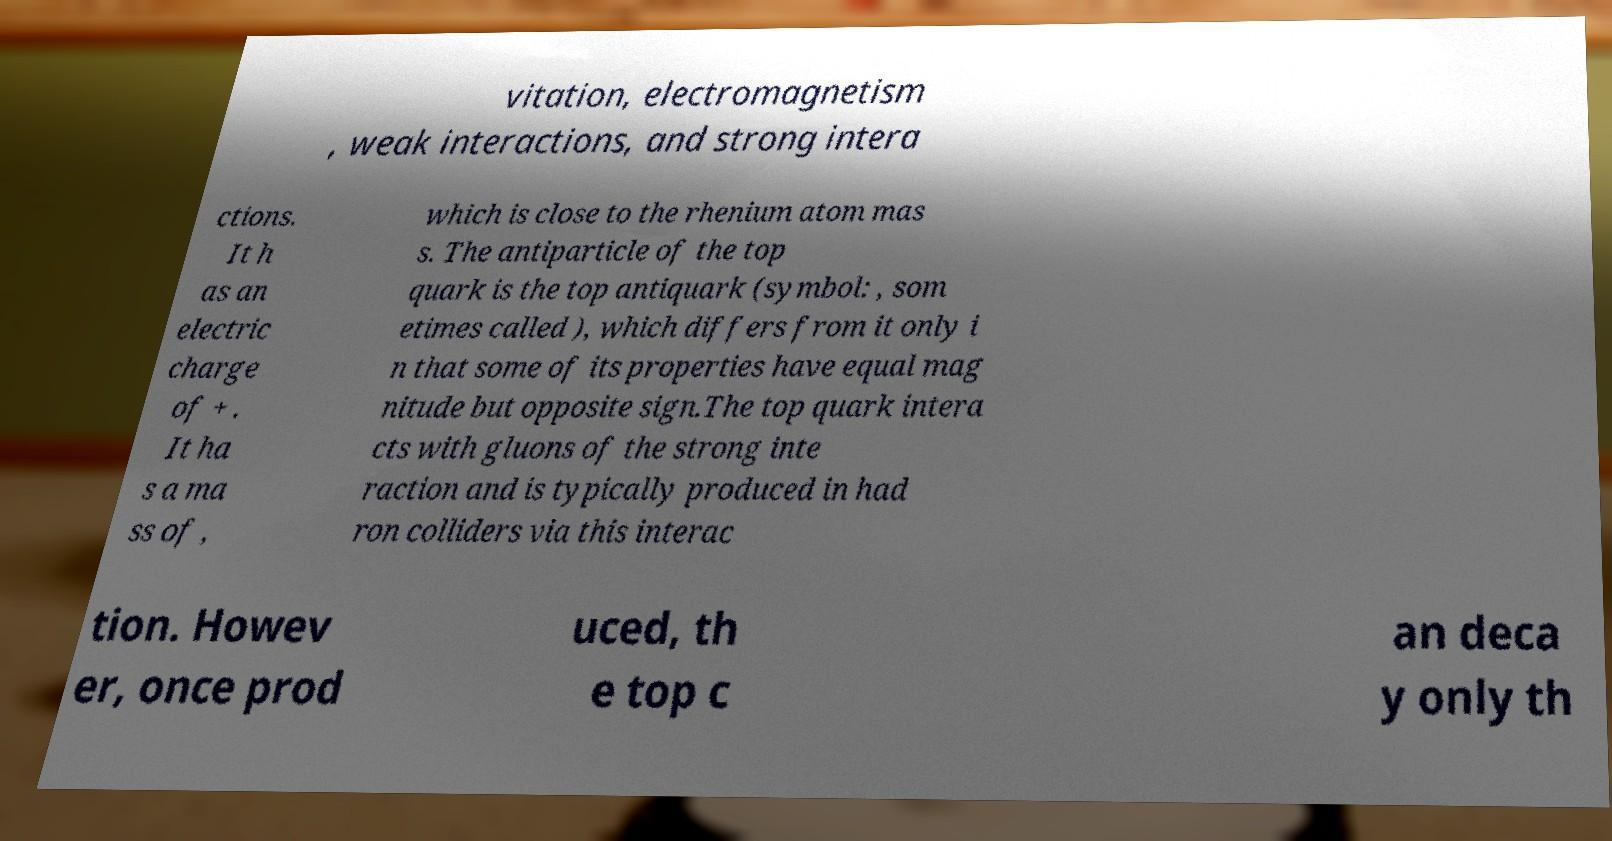What messages or text are displayed in this image? I need them in a readable, typed format. vitation, electromagnetism , weak interactions, and strong intera ctions. It h as an electric charge of + . It ha s a ma ss of , which is close to the rhenium atom mas s. The antiparticle of the top quark is the top antiquark (symbol: , som etimes called ), which differs from it only i n that some of its properties have equal mag nitude but opposite sign.The top quark intera cts with gluons of the strong inte raction and is typically produced in had ron colliders via this interac tion. Howev er, once prod uced, th e top c an deca y only th 